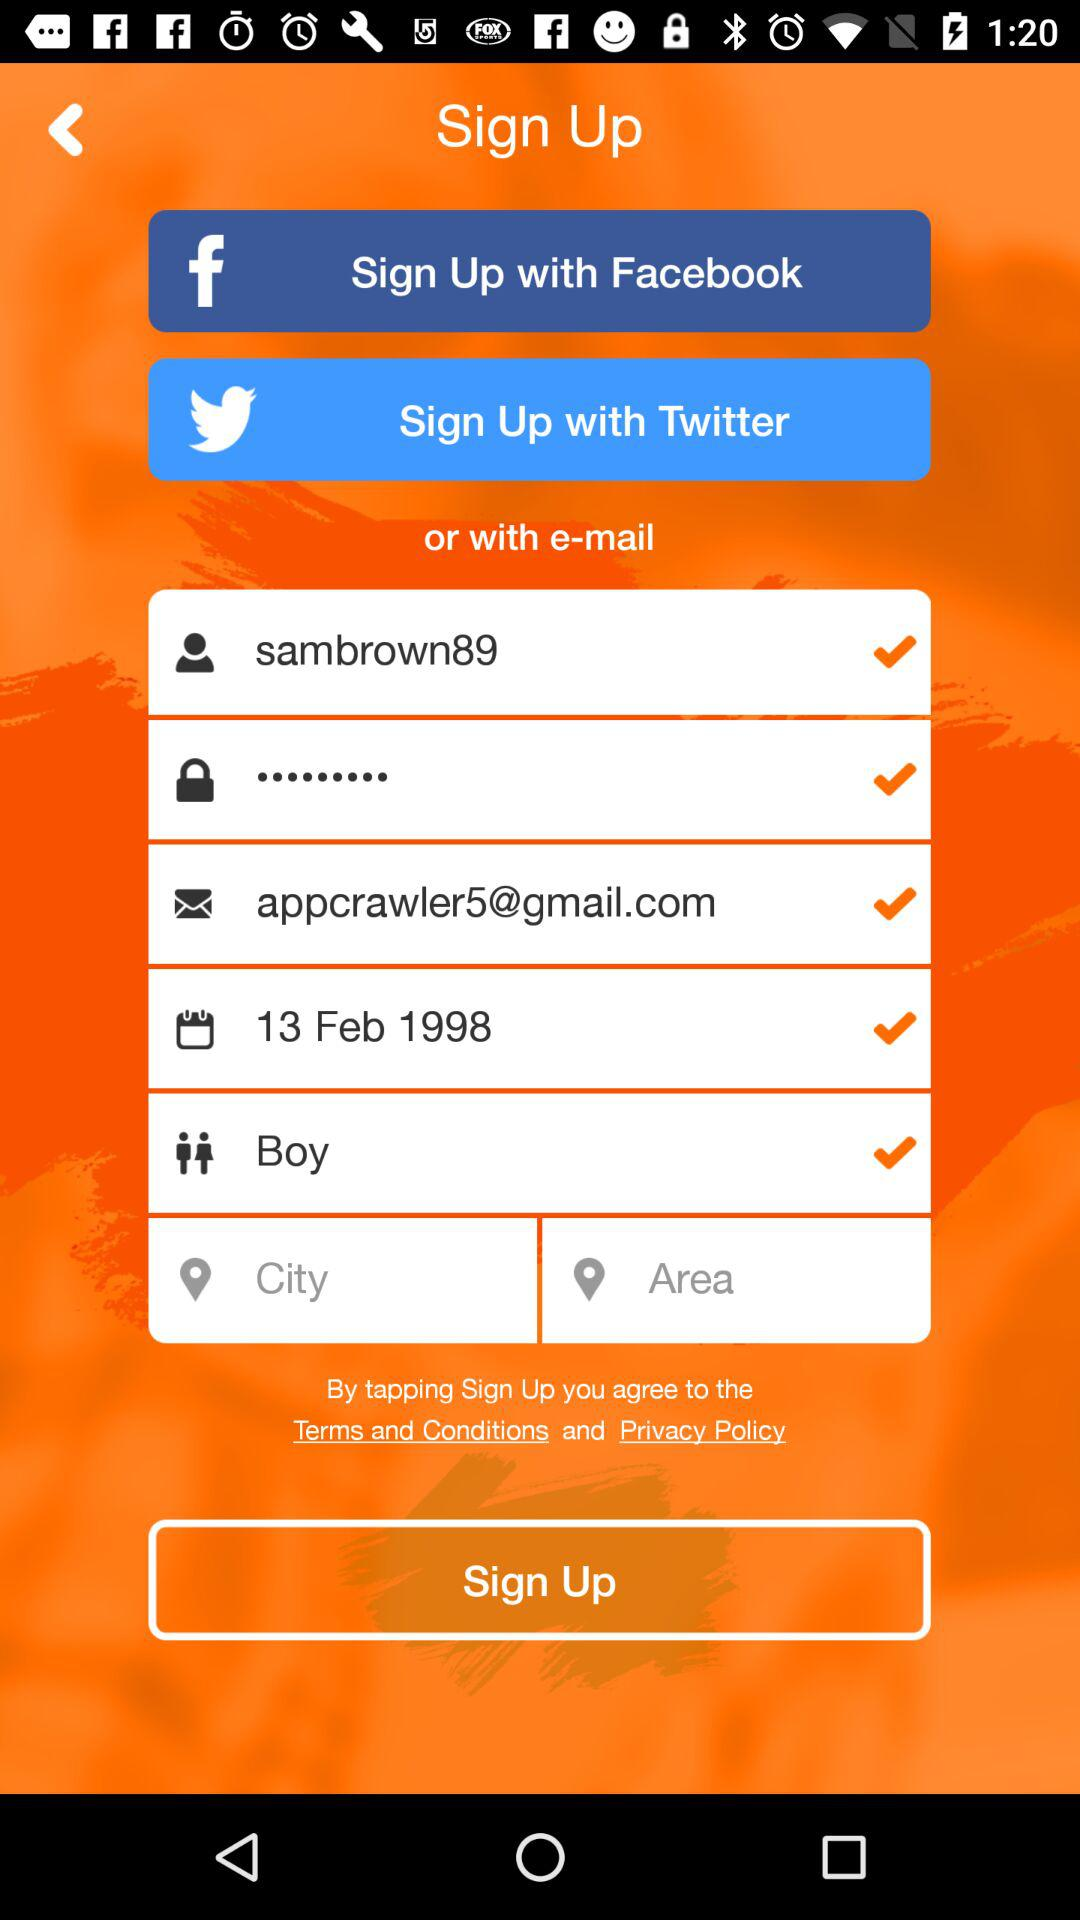Which accounts can I use to sign up? You can sign up with "Facebook", "Twitter" and "e-mail". 